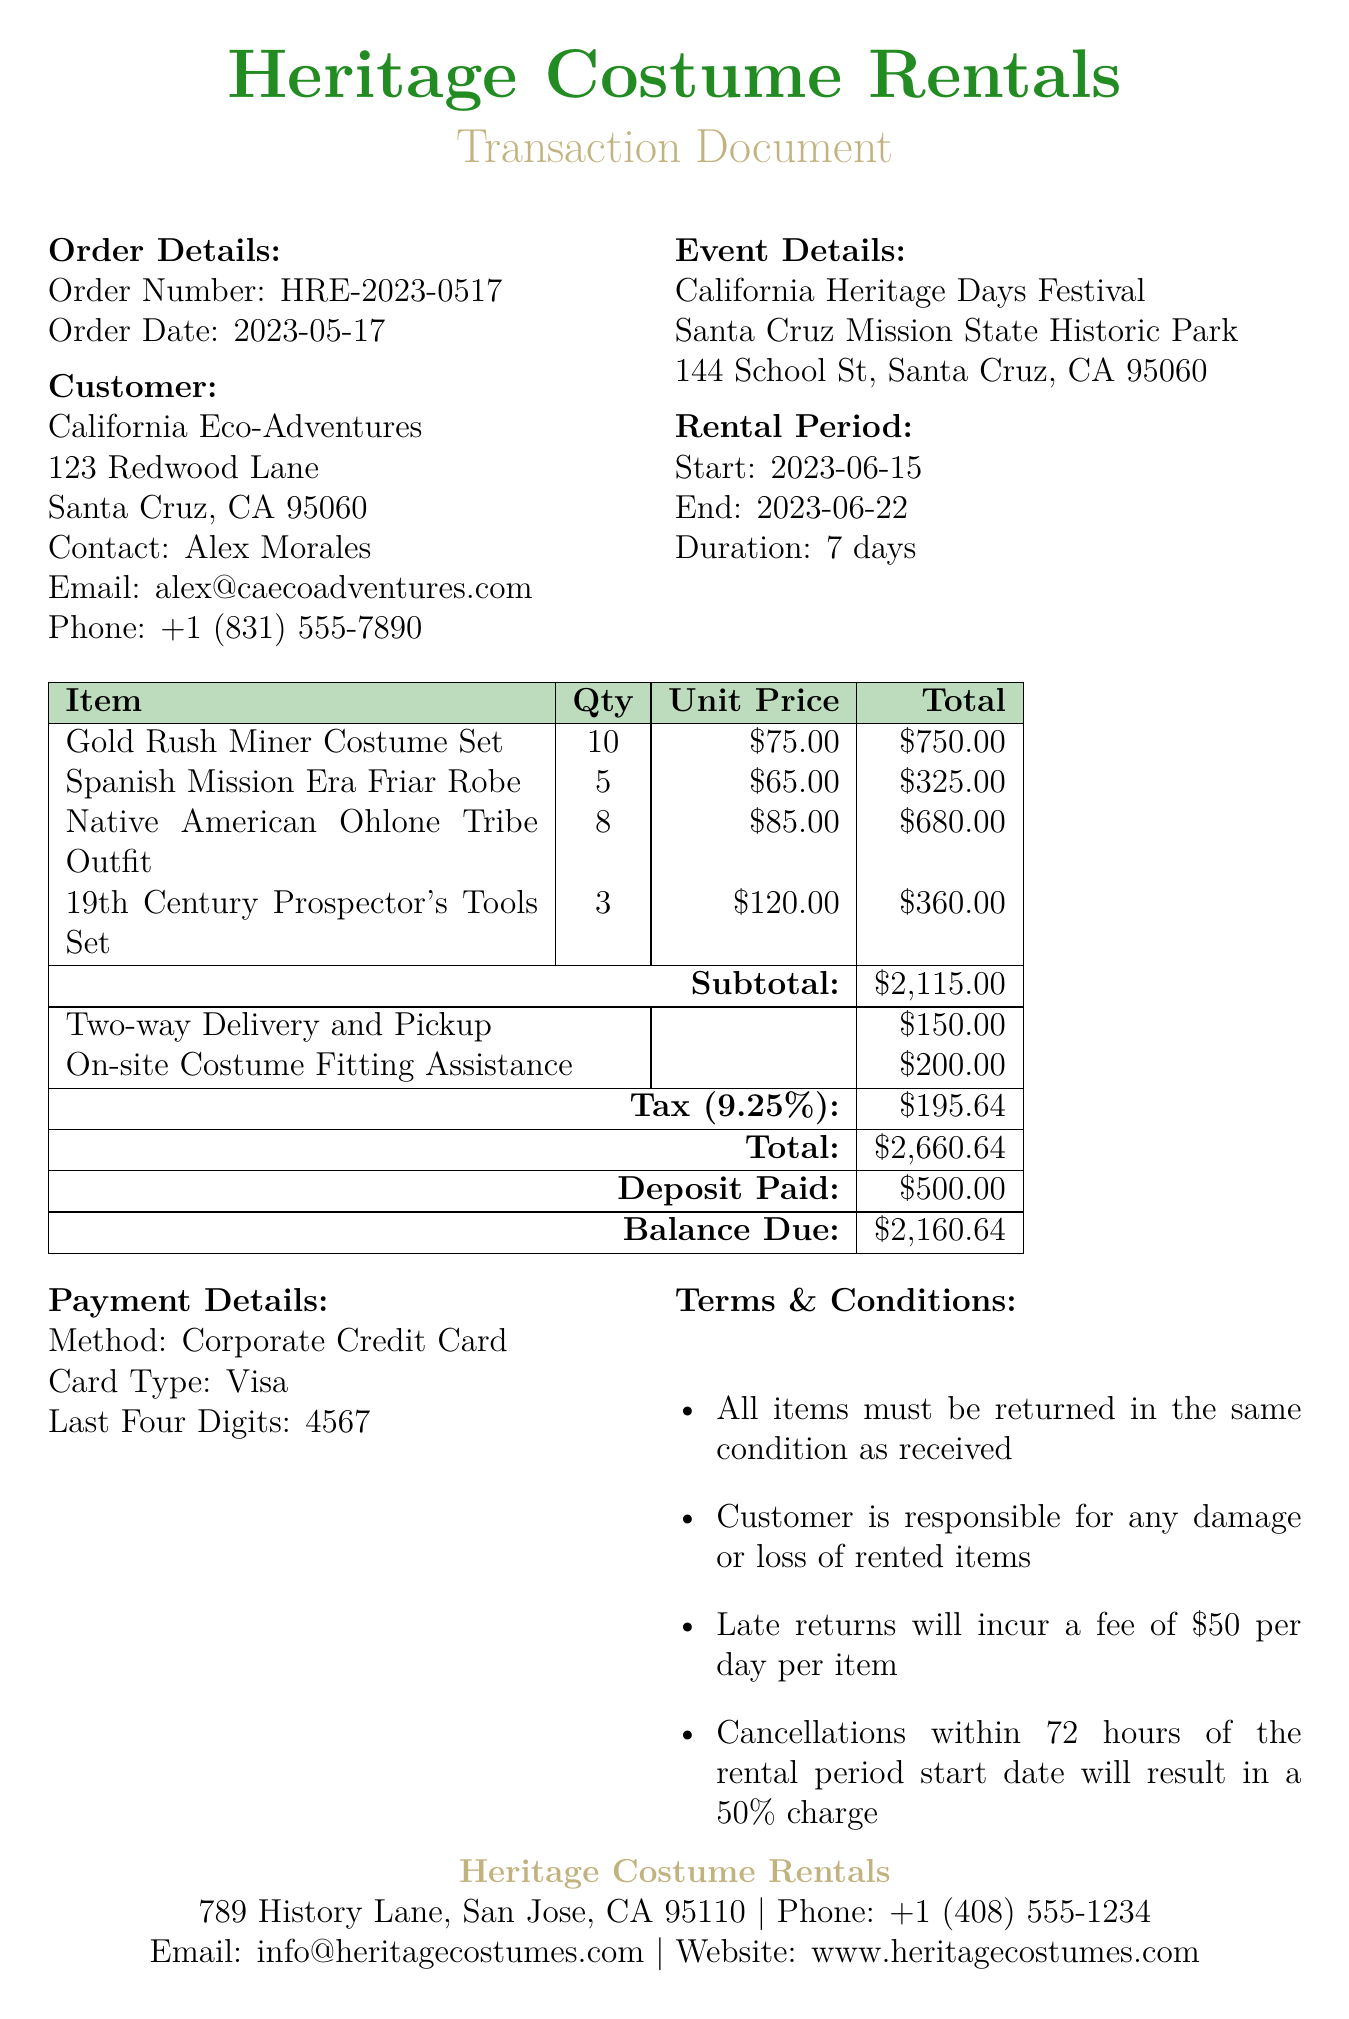what is the order number? The order number is a unique identifier for the transaction, found in the order details.
Answer: HRE-2023-0517 who is the contact person for the customer? The contact person is the individual listed for communication regarding the transaction.
Answer: Alex Morales how many units of the Gold Rush Miner Costume Set were rented? This information is found in the rental items section, indicating the quantity rented.
Answer: 10 what is the total amount due before the deposit? The total amount before the deposit can be calculated by adding the subtotal and the fees, then subtracting the deposit paid.
Answer: 2160.64 what is the duration of the rental period? The duration is specifically stated in the rental period section.
Answer: 7 days what is the tax rate applied to the transaction? The tax rate, mentioned in the payment details, indicates the percentage added to the subtotal.
Answer: 9.25% what service incurs an additional fee of two hundred dollars? This refers to a specific additional service outlined in the additional services section.
Answer: On-site Costume Fitting Assistance what is the address of the venue for the event? The venue address is provided under the event details in the document.
Answer: 144 School St, Santa Cruz, CA 95060 what happens in case of a late return? This detail is mentioned in the terms & conditions, outlining the penalty for late returns.
Answer: $50 per day per item 